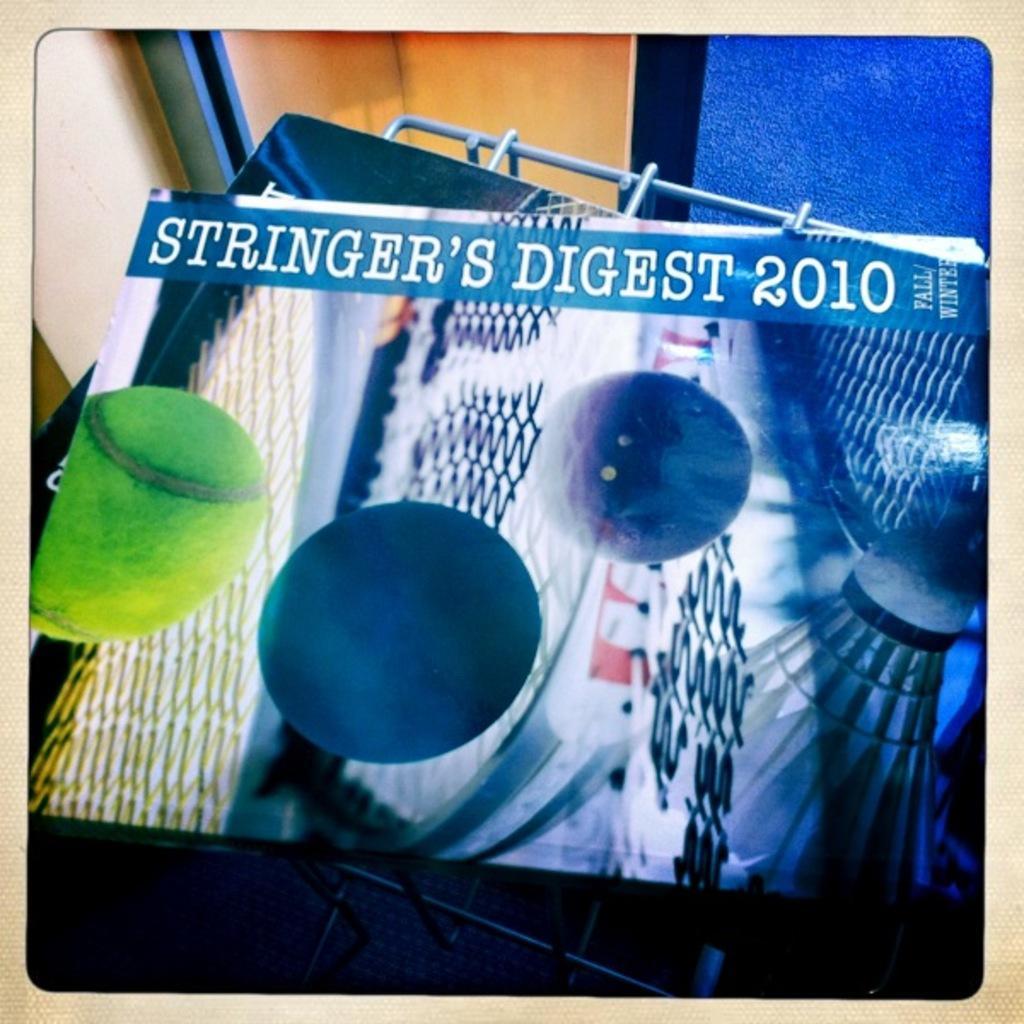How would you summarize this image in a sentence or two? In the image we can see a stand, on the stand we can see some papers. At the top of the image we can see wall. 